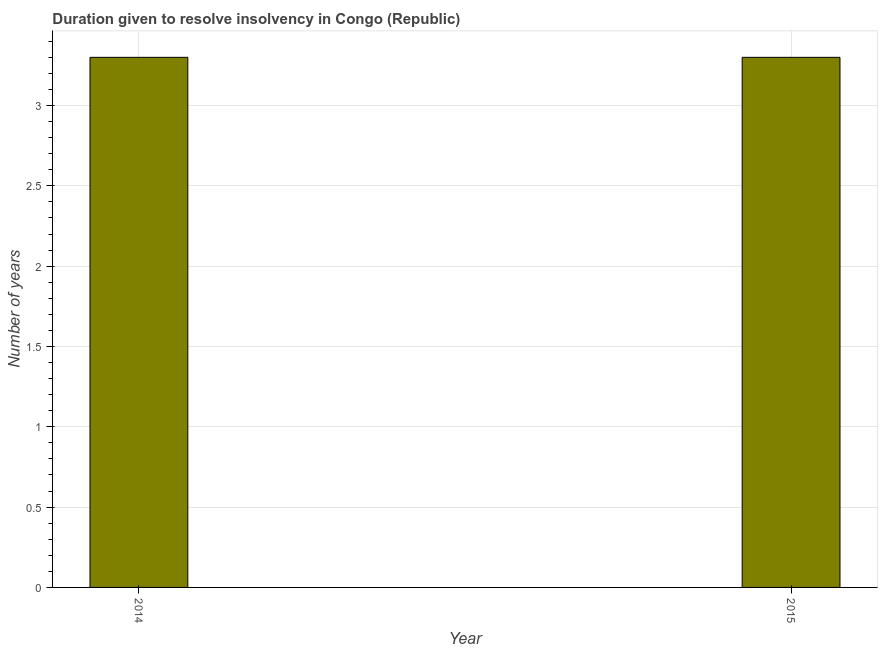Does the graph contain any zero values?
Provide a succinct answer. No. Does the graph contain grids?
Ensure brevity in your answer.  Yes. What is the title of the graph?
Provide a succinct answer. Duration given to resolve insolvency in Congo (Republic). What is the label or title of the X-axis?
Provide a succinct answer. Year. What is the label or title of the Y-axis?
Keep it short and to the point. Number of years. Across all years, what is the maximum number of years to resolve insolvency?
Provide a short and direct response. 3.3. Across all years, what is the minimum number of years to resolve insolvency?
Provide a succinct answer. 3.3. In which year was the number of years to resolve insolvency minimum?
Your answer should be compact. 2014. What is the sum of the number of years to resolve insolvency?
Provide a succinct answer. 6.6. What is the difference between the number of years to resolve insolvency in 2014 and 2015?
Ensure brevity in your answer.  0. In how many years, is the number of years to resolve insolvency greater than 2.5 ?
Your response must be concise. 2. Do a majority of the years between 2015 and 2014 (inclusive) have number of years to resolve insolvency greater than 2 ?
Provide a short and direct response. No. What is the ratio of the number of years to resolve insolvency in 2014 to that in 2015?
Your answer should be compact. 1. Are all the bars in the graph horizontal?
Offer a very short reply. No. What is the Number of years of 2015?
Your answer should be very brief. 3.3. 